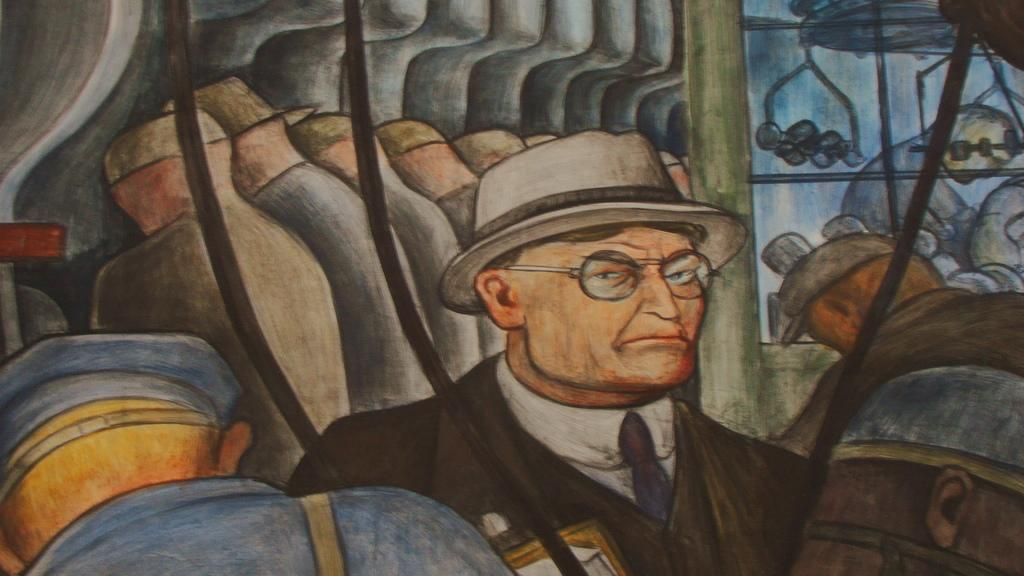What is the main subject of the image? There is a painting in the image. What is the painting depicting? The painting depicts a man in the foreground and other people in the background. What is the manager's role in the painting? There is no mention of a manager in the image or the painting, so it is not possible to determine their role. 